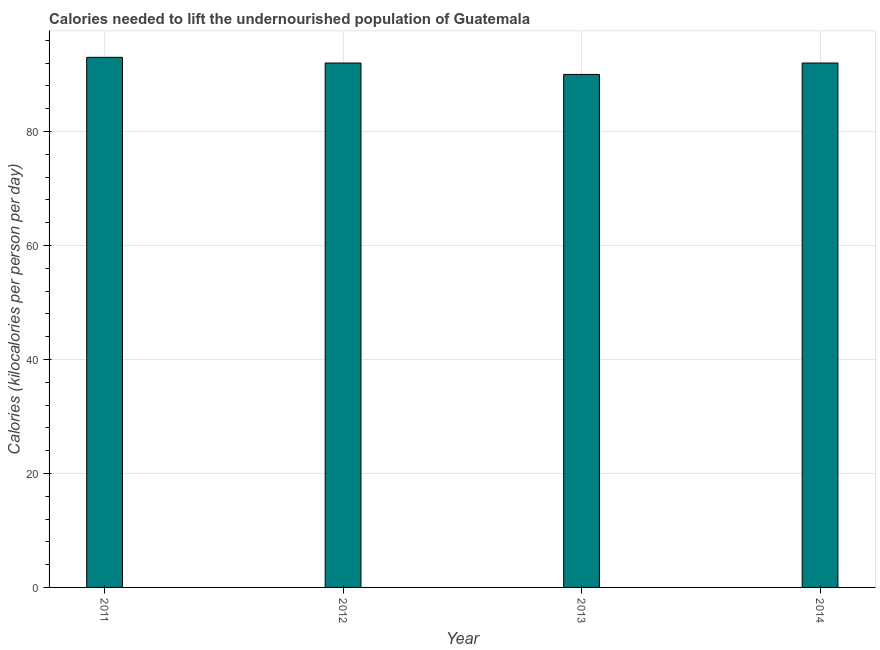Does the graph contain any zero values?
Your answer should be very brief. No. What is the title of the graph?
Give a very brief answer. Calories needed to lift the undernourished population of Guatemala. What is the label or title of the Y-axis?
Your answer should be very brief. Calories (kilocalories per person per day). What is the depth of food deficit in 2013?
Your answer should be very brief. 90. Across all years, what is the maximum depth of food deficit?
Ensure brevity in your answer.  93. What is the sum of the depth of food deficit?
Offer a very short reply. 367. What is the difference between the depth of food deficit in 2012 and 2014?
Offer a very short reply. 0. What is the average depth of food deficit per year?
Keep it short and to the point. 91. What is the median depth of food deficit?
Provide a succinct answer. 92. In how many years, is the depth of food deficit greater than 76 kilocalories?
Keep it short and to the point. 4. What is the ratio of the depth of food deficit in 2011 to that in 2012?
Make the answer very short. 1.01. Is the depth of food deficit in 2012 less than that in 2013?
Offer a very short reply. No. What is the difference between the highest and the second highest depth of food deficit?
Your answer should be compact. 1. Are all the bars in the graph horizontal?
Give a very brief answer. No. What is the difference between two consecutive major ticks on the Y-axis?
Provide a short and direct response. 20. Are the values on the major ticks of Y-axis written in scientific E-notation?
Your answer should be compact. No. What is the Calories (kilocalories per person per day) in 2011?
Offer a very short reply. 93. What is the Calories (kilocalories per person per day) of 2012?
Provide a succinct answer. 92. What is the Calories (kilocalories per person per day) of 2013?
Ensure brevity in your answer.  90. What is the Calories (kilocalories per person per day) of 2014?
Ensure brevity in your answer.  92. What is the difference between the Calories (kilocalories per person per day) in 2011 and 2013?
Offer a terse response. 3. What is the difference between the Calories (kilocalories per person per day) in 2011 and 2014?
Offer a terse response. 1. What is the difference between the Calories (kilocalories per person per day) in 2012 and 2013?
Your response must be concise. 2. What is the difference between the Calories (kilocalories per person per day) in 2012 and 2014?
Offer a terse response. 0. What is the difference between the Calories (kilocalories per person per day) in 2013 and 2014?
Offer a very short reply. -2. What is the ratio of the Calories (kilocalories per person per day) in 2011 to that in 2013?
Make the answer very short. 1.03. What is the ratio of the Calories (kilocalories per person per day) in 2012 to that in 2013?
Offer a very short reply. 1.02. 